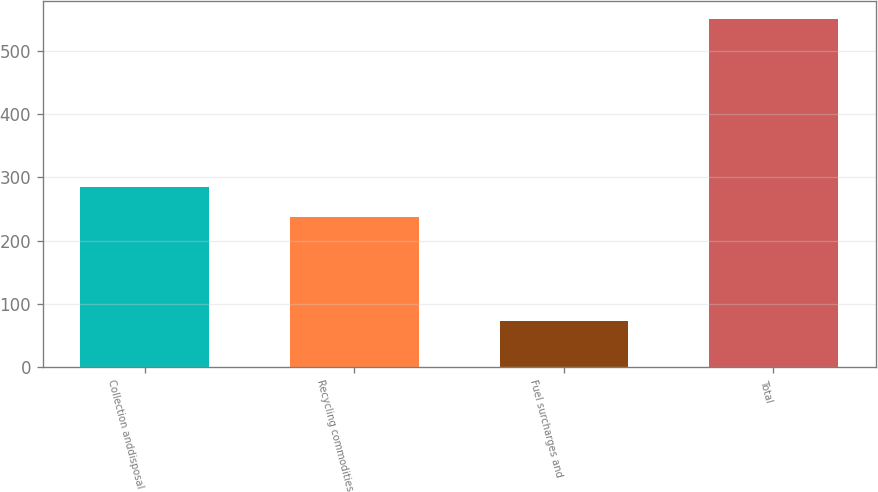Convert chart. <chart><loc_0><loc_0><loc_500><loc_500><bar_chart><fcel>Collection anddisposal<fcel>Recycling commodities<fcel>Fuel surcharges and<fcel>Total<nl><fcel>284.8<fcel>237<fcel>73<fcel>551<nl></chart> 